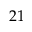<formula> <loc_0><loc_0><loc_500><loc_500>2 1</formula> 